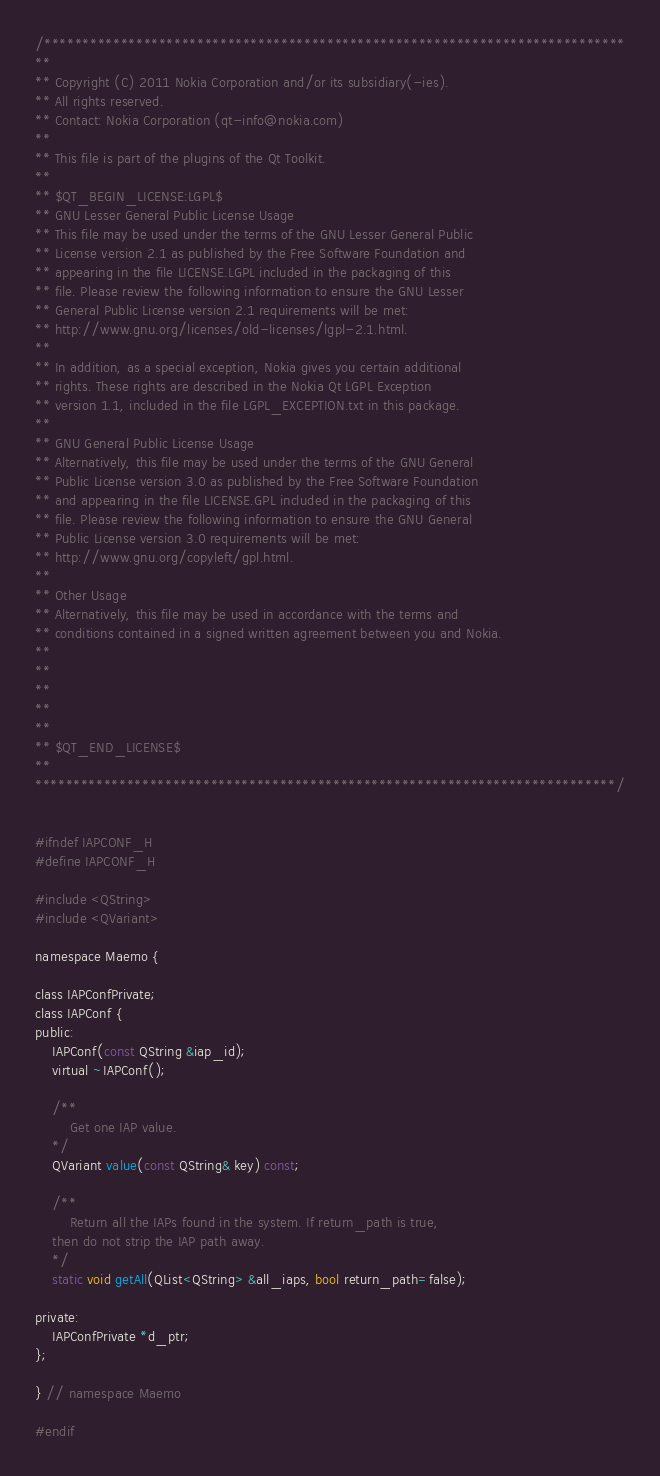<code> <loc_0><loc_0><loc_500><loc_500><_C_>/****************************************************************************
**
** Copyright (C) 2011 Nokia Corporation and/or its subsidiary(-ies).
** All rights reserved.
** Contact: Nokia Corporation (qt-info@nokia.com)
**
** This file is part of the plugins of the Qt Toolkit.
**
** $QT_BEGIN_LICENSE:LGPL$
** GNU Lesser General Public License Usage
** This file may be used under the terms of the GNU Lesser General Public
** License version 2.1 as published by the Free Software Foundation and
** appearing in the file LICENSE.LGPL included in the packaging of this
** file. Please review the following information to ensure the GNU Lesser
** General Public License version 2.1 requirements will be met:
** http://www.gnu.org/licenses/old-licenses/lgpl-2.1.html.
**
** In addition, as a special exception, Nokia gives you certain additional
** rights. These rights are described in the Nokia Qt LGPL Exception
** version 1.1, included in the file LGPL_EXCEPTION.txt in this package.
**
** GNU General Public License Usage
** Alternatively, this file may be used under the terms of the GNU General
** Public License version 3.0 as published by the Free Software Foundation
** and appearing in the file LICENSE.GPL included in the packaging of this
** file. Please review the following information to ensure the GNU General
** Public License version 3.0 requirements will be met:
** http://www.gnu.org/copyleft/gpl.html.
**
** Other Usage
** Alternatively, this file may be used in accordance with the terms and
** conditions contained in a signed written agreement between you and Nokia.
**
**
**
**
**
** $QT_END_LICENSE$
**
****************************************************************************/


#ifndef IAPCONF_H
#define IAPCONF_H

#include <QString>
#include <QVariant>

namespace Maemo {

class IAPConfPrivate;
class IAPConf {
public:
    IAPConf(const QString &iap_id);
    virtual ~IAPConf();

    /**
        Get one IAP value.
    */
    QVariant value(const QString& key) const;

    /**
        Return all the IAPs found in the system. If return_path is true,
	then do not strip the IAP path away.
    */
    static void getAll(QList<QString> &all_iaps, bool return_path=false);

private:
    IAPConfPrivate *d_ptr;
};

} // namespace Maemo

#endif
</code> 